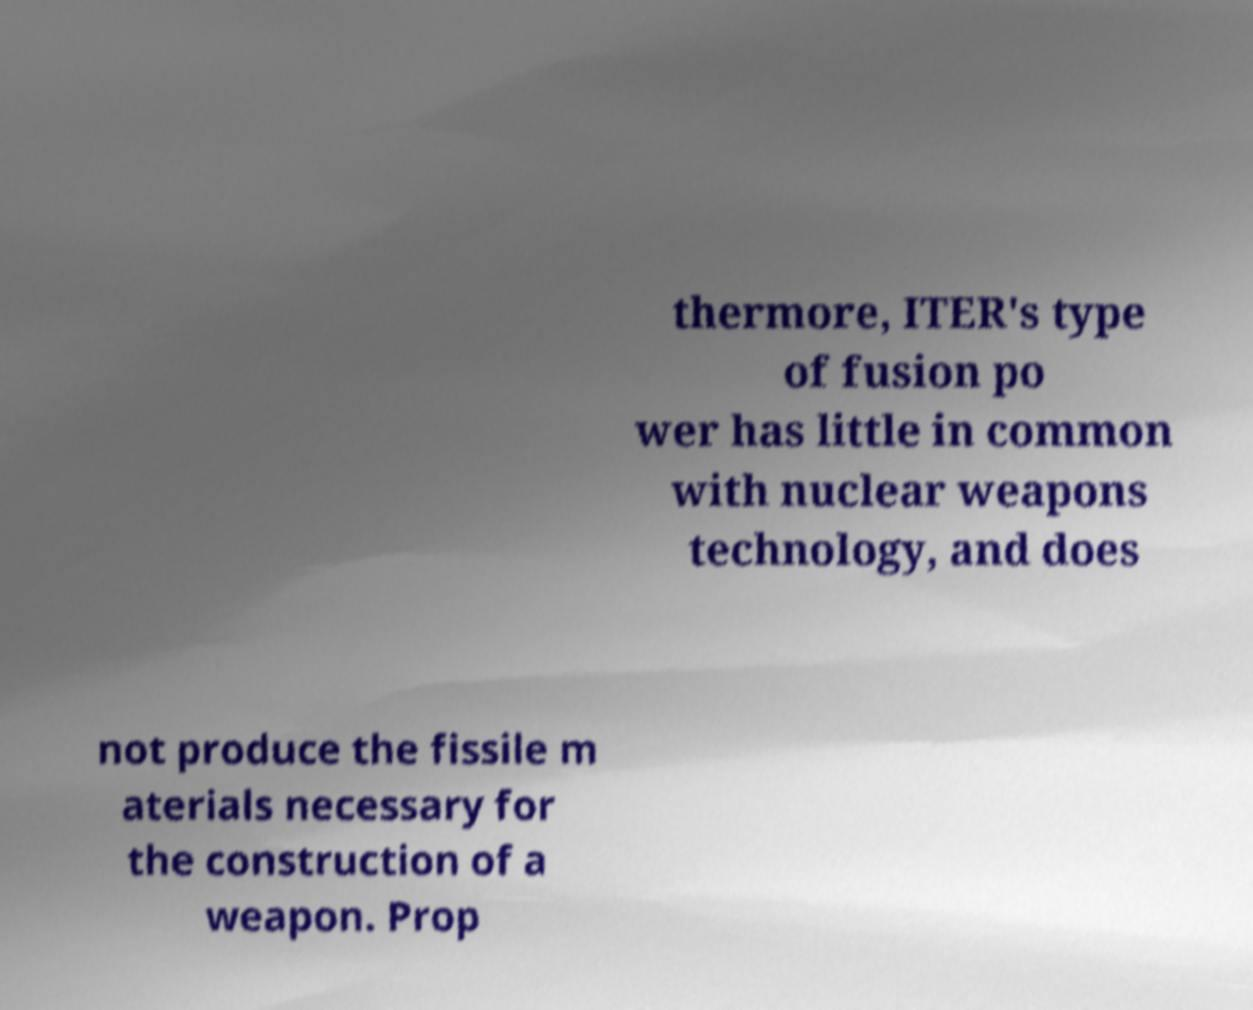Please read and relay the text visible in this image. What does it say? thermore, ITER's type of fusion po wer has little in common with nuclear weapons technology, and does not produce the fissile m aterials necessary for the construction of a weapon. Prop 